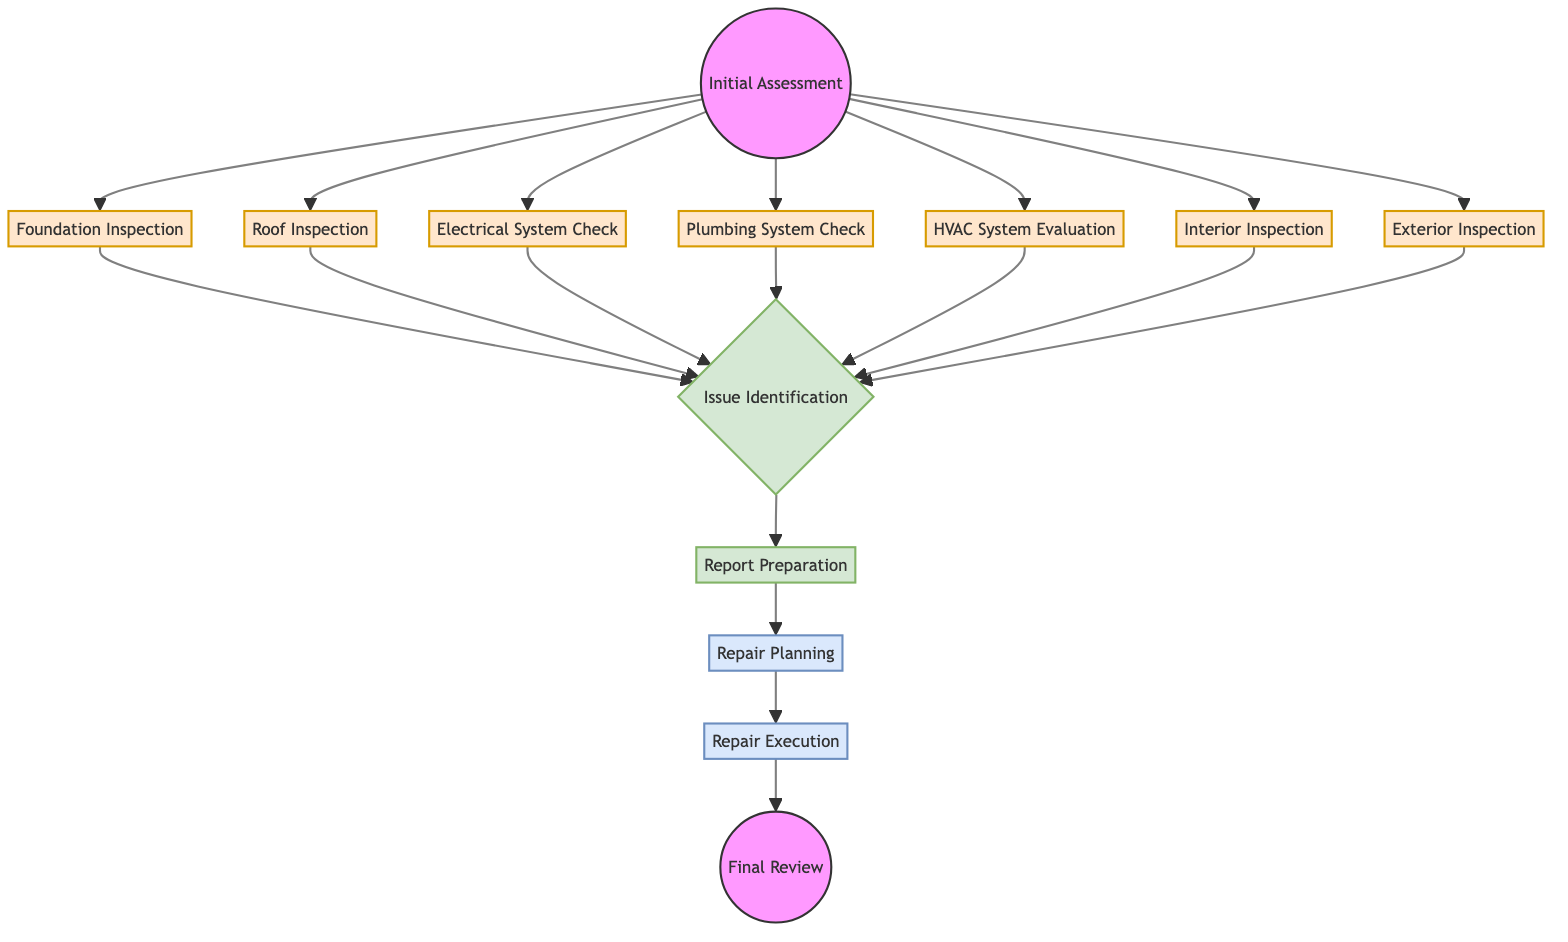What is the starting point of the home inspection process? The diagram indicates that the "Initial Assessment" is the first step in the sequence of the home inspection process, as it is the only node with no incoming edges.
Answer: Initial Assessment How many inspection stages are there after the initial assessment? After the "Initial Assessment," there are seven subsequent inspection nodes leading to "Issue Identification." They include Foundation Inspection, Roof Inspection, Electrical System Check, Plumbing System Check, HVAC System Evaluation, Interior Inspection, and Exterior Inspection.
Answer: Seven Which stage leads directly to report preparation? The "Issue Identification" is the only node that directly leads to the "Report Preparation," as indicated by the directed edge from "Issue Identification" to "Report Preparation."
Answer: Issue Identification What is the last step in the home inspection process? The last step outlined in the diagram is the "Final Review," which is the only node that has no outgoing edges and follows the "Repair Execution" stage.
Answer: Final Review What stage follows "Report Preparation"? According to the diagram, "Repair Planning" follows "Report Preparation," as indicated by the directed edge going from "Report Preparation" to "Repair Planning."
Answer: Repair Planning How are the inspection nodes categorized in the diagram? The inspection nodes, which include Foundation Inspection, Roof Inspection, Electrical System Check, Plumbing System Check, HVAC System Evaluation, Interior Inspection, and Exterior Inspection, are visually categorized with a specific color class known as 'inspection'.
Answer: Inspection nodes How many edges are there leading into "Issue Identification"? There are seven edges leading into the "Issue Identification" node, each coming from the different inspection stages, as represented in the directed graph.
Answer: Seven What is the sequence of steps after Issue Identification? The sequence following "Issue Identification" is "Report Preparation," "Repair Planning," "Repair Execution," and finally "Final Review," showing the flow from identification to review.
Answer: Report Preparation, Repair Planning, Repair Execution, Final Review Which node acts as a transition between report preparation and repair planning? The "Report Preparation" node serves as a transition between the issue identification and repair planning, as the sequence flows from "Report Preparation" to "Repair Planning."
Answer: Report Preparation 